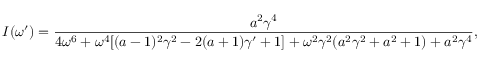Convert formula to latex. <formula><loc_0><loc_0><loc_500><loc_500>I ( \omega ^ { \prime } ) = \frac { a ^ { 2 } \gamma ^ { 4 } } { 4 \omega ^ { 6 } + \omega ^ { 4 } [ ( a - 1 ) ^ { 2 } \gamma ^ { 2 } - 2 ( a + 1 ) \gamma ^ { \prime } + 1 ] + \omega ^ { 2 } \gamma ^ { 2 } ( a ^ { 2 } \gamma ^ { 2 } + a ^ { 2 } + 1 ) + a ^ { 2 } \gamma ^ { 4 } } ,</formula> 